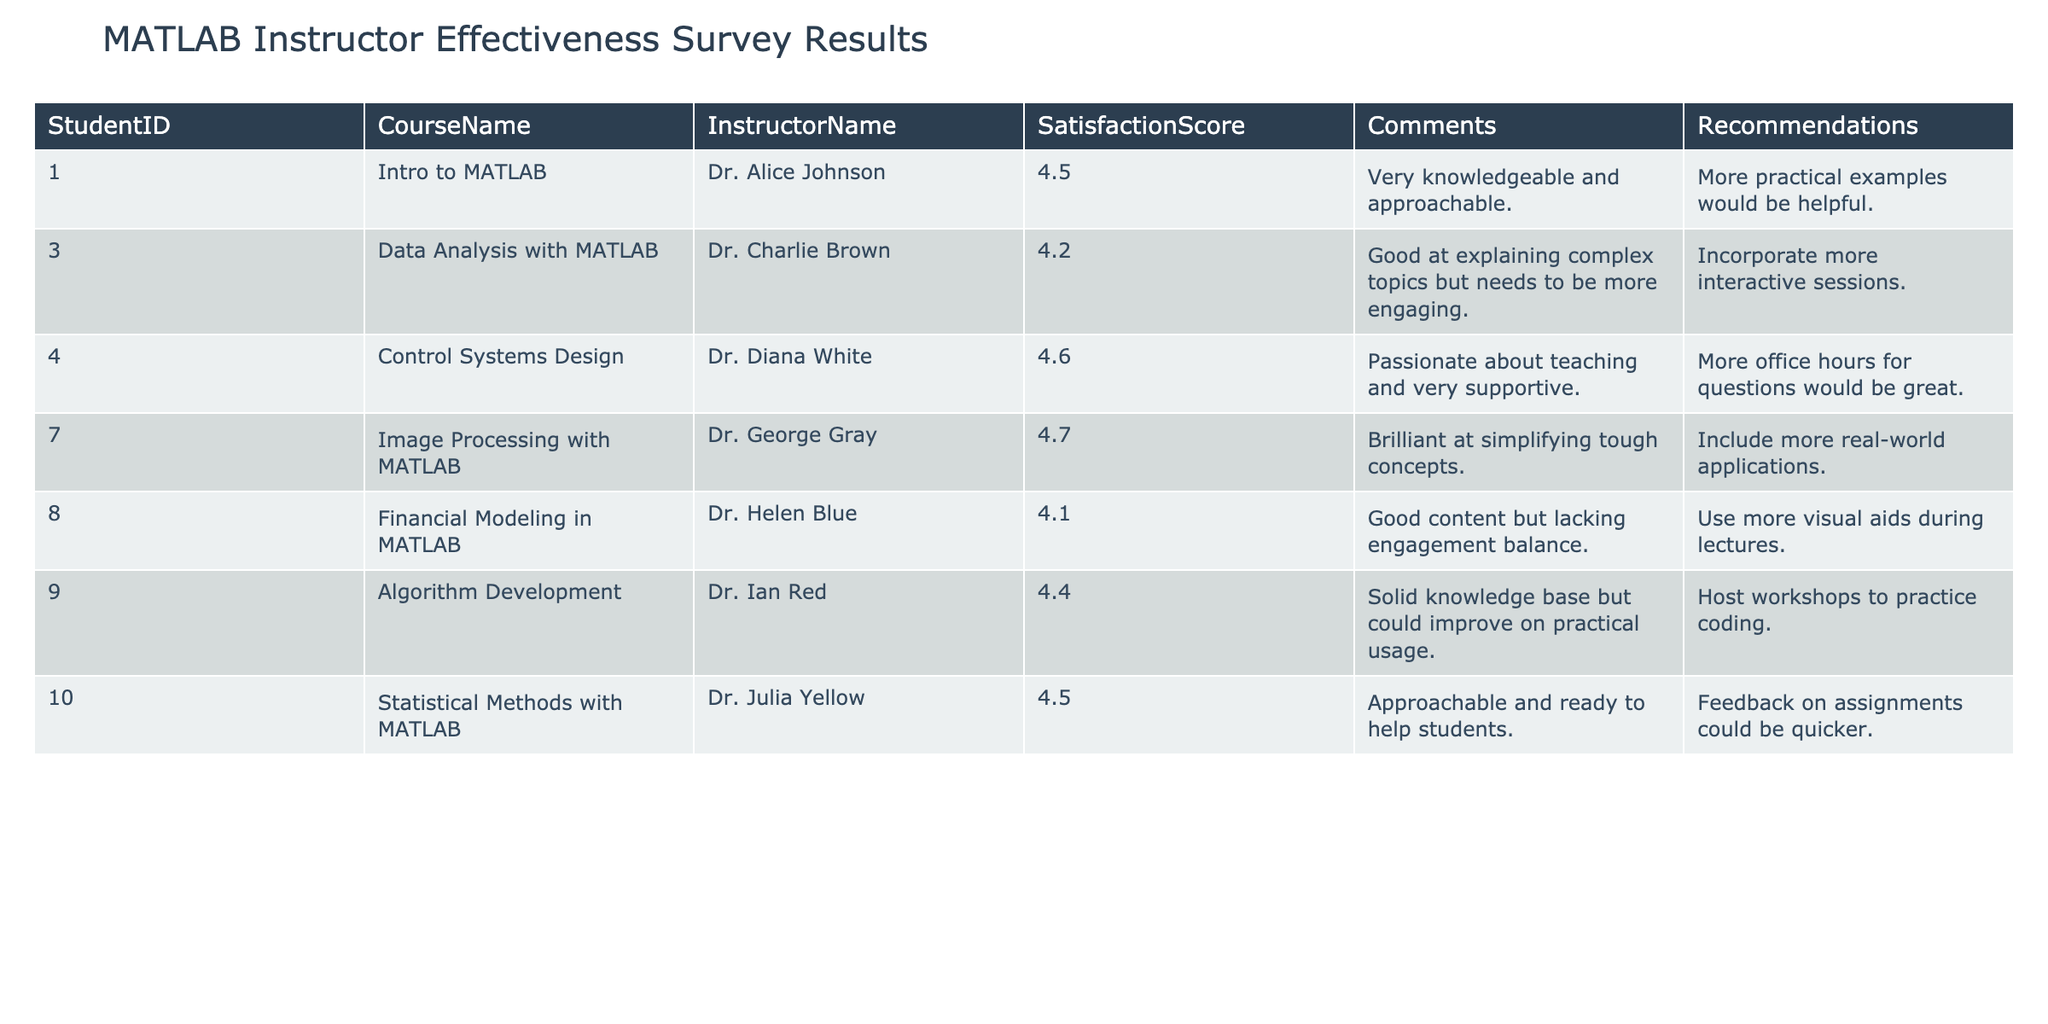What is the highest Satisfaction Score among the instructors? Looking at the Satisfaction Score column, the highest value is 4.7. This corresponds to Dr. George Gray from the "Image Processing with MATLAB" course.
Answer: 4.7 What comments did Dr. Helen Blue receive? Dr. Helen Blue received the comment: "Good content but lacking engagement balance." This is found in the Comments column for her entry.
Answer: Good content but lacking engagement balance How many instructors have a Satisfaction Score of 4.4 or higher? By checking the Satisfaction Score column, the scores of 4.5, 4.6, and 4.7 are all 4.4 or higher. This results in a total of six instructors: Dr. Alice Johnson, Dr. Diana White, Dr. George Gray, Dr. Ian Red, Dr. Julia Yellow, and Dr. Helen Blue.
Answer: 6 What is the average Satisfaction Score for all instructors? To calculate the average, sum all the Satisfaction Scores: (4.5 + 4.2 + 4.6 + 4.7 + 4.1 + 4.4 + 4.5) = 26.0. There are 7 instructors, so the average is 26.0 / 7 ≈ 3.71.
Answer: 3.71 Did any instructor receive a recommendation for more office hours? Yes, Dr. Diana White received the recommendation: "More office hours for questions would be great," which indicates a request for increased availability.
Answer: Yes What percentage of students recommended more interactive sessions? From the table, only one instructor (Dr. Charlie Brown) received a recommendation for more interactive sessions. Since there are 7 instructors in total, the percentage is (1 / 7) * 100 ≈ 14.29%.
Answer: 14.29% Which instructor received the comment about needing quicker feedback on assignments? Dr. Julia Yellow received the comment: "Feedback on assignments could be quicker." This can be found in her row in the Comments column.
Answer: Dr. Julia Yellow Which course has the lowest Satisfaction Score, and what is that score? The course with the lowest Satisfaction Score is "Financial Modeling in MATLAB," taught by Dr. Helen Blue, with a score of 4.1. This is the smallest value in the Satisfaction Score column.
Answer: Financial Modeling in MATLAB, 4.1 